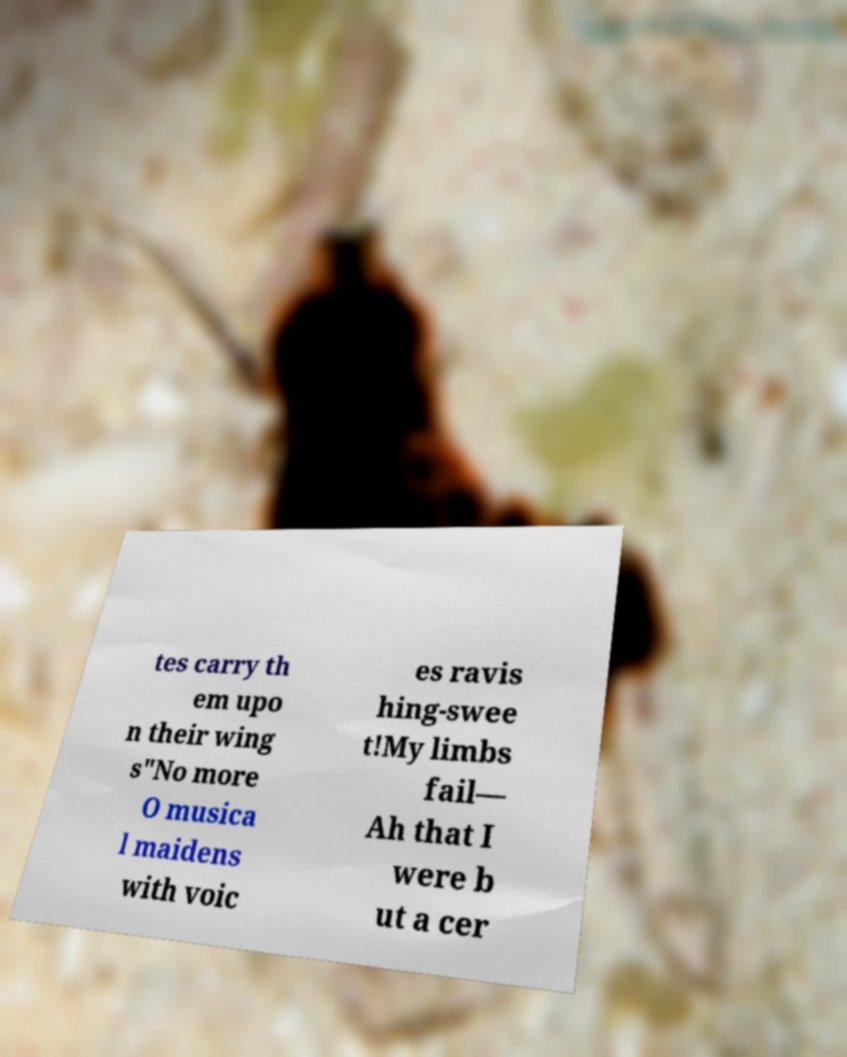Please identify and transcribe the text found in this image. tes carry th em upo n their wing s"No more O musica l maidens with voic es ravis hing-swee t!My limbs fail— Ah that I were b ut a cer 